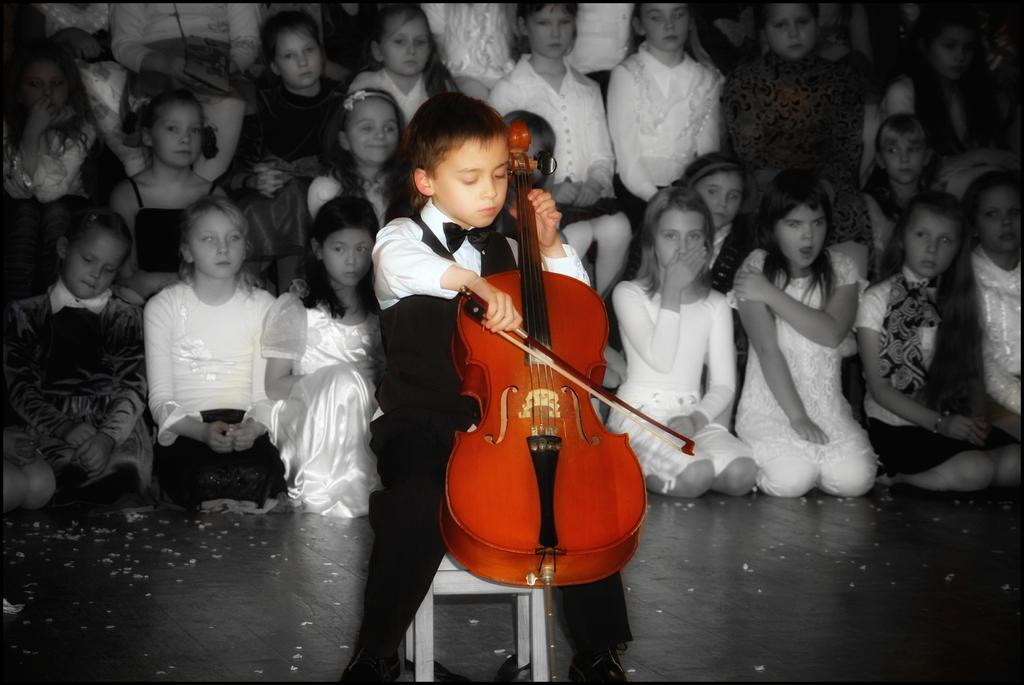What is the boy in the image doing? The boy is sitting on a chair in the image. What is the boy holding in the image? The boy is holding a violin. What can be seen in the background of the image? There is a group of people in the background of the image. What might the group of people be doing in the image? The group of people are likely sitting, serving as an audience. What type of toothpaste is the boy using to play the violin in the image? There is no toothpaste present in the image, and the boy is not using any toothpaste to play the violin. 